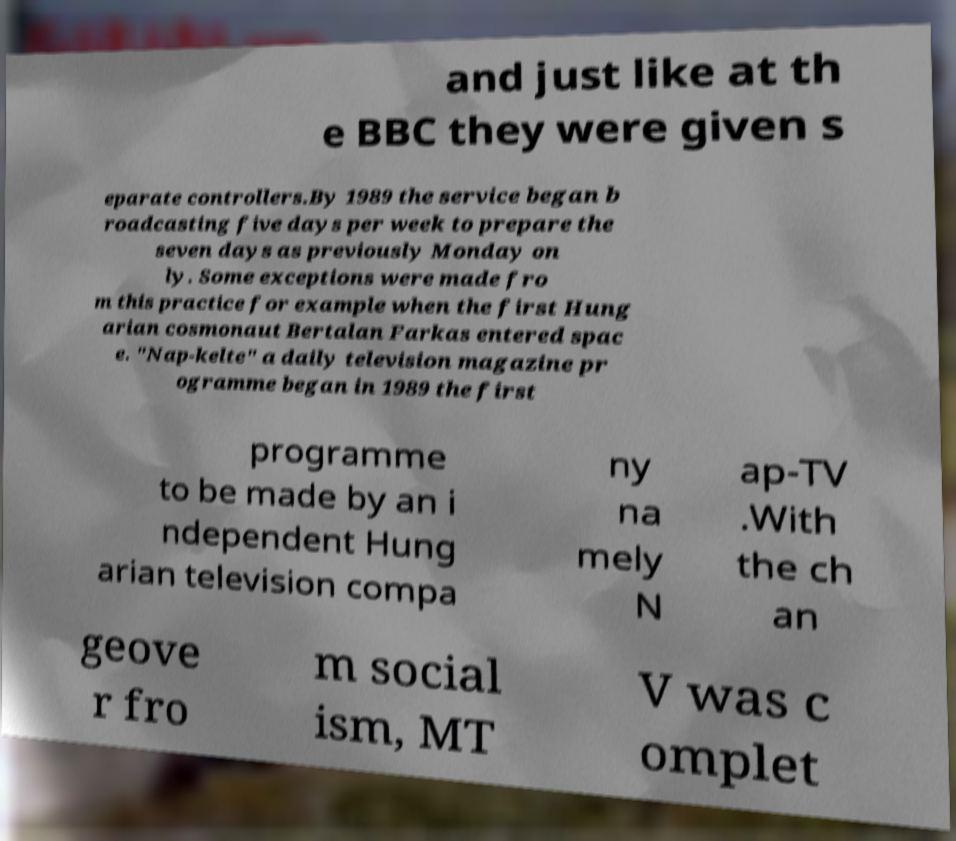For documentation purposes, I need the text within this image transcribed. Could you provide that? and just like at th e BBC they were given s eparate controllers.By 1989 the service began b roadcasting five days per week to prepare the seven days as previously Monday on ly. Some exceptions were made fro m this practice for example when the first Hung arian cosmonaut Bertalan Farkas entered spac e. "Nap-kelte" a daily television magazine pr ogramme began in 1989 the first programme to be made by an i ndependent Hung arian television compa ny na mely N ap-TV .With the ch an geove r fro m social ism, MT V was c omplet 